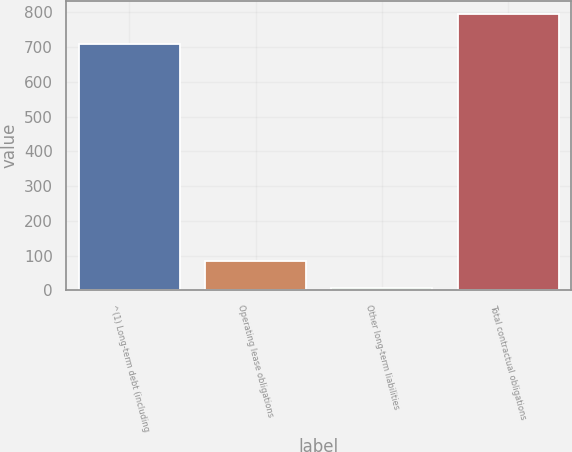<chart> <loc_0><loc_0><loc_500><loc_500><bar_chart><fcel>^(1) Long-term debt (including<fcel>Operating lease obligations<fcel>Other long-term liabilities<fcel>Total contractual obligations<nl><fcel>710<fcel>84.8<fcel>6<fcel>794<nl></chart> 